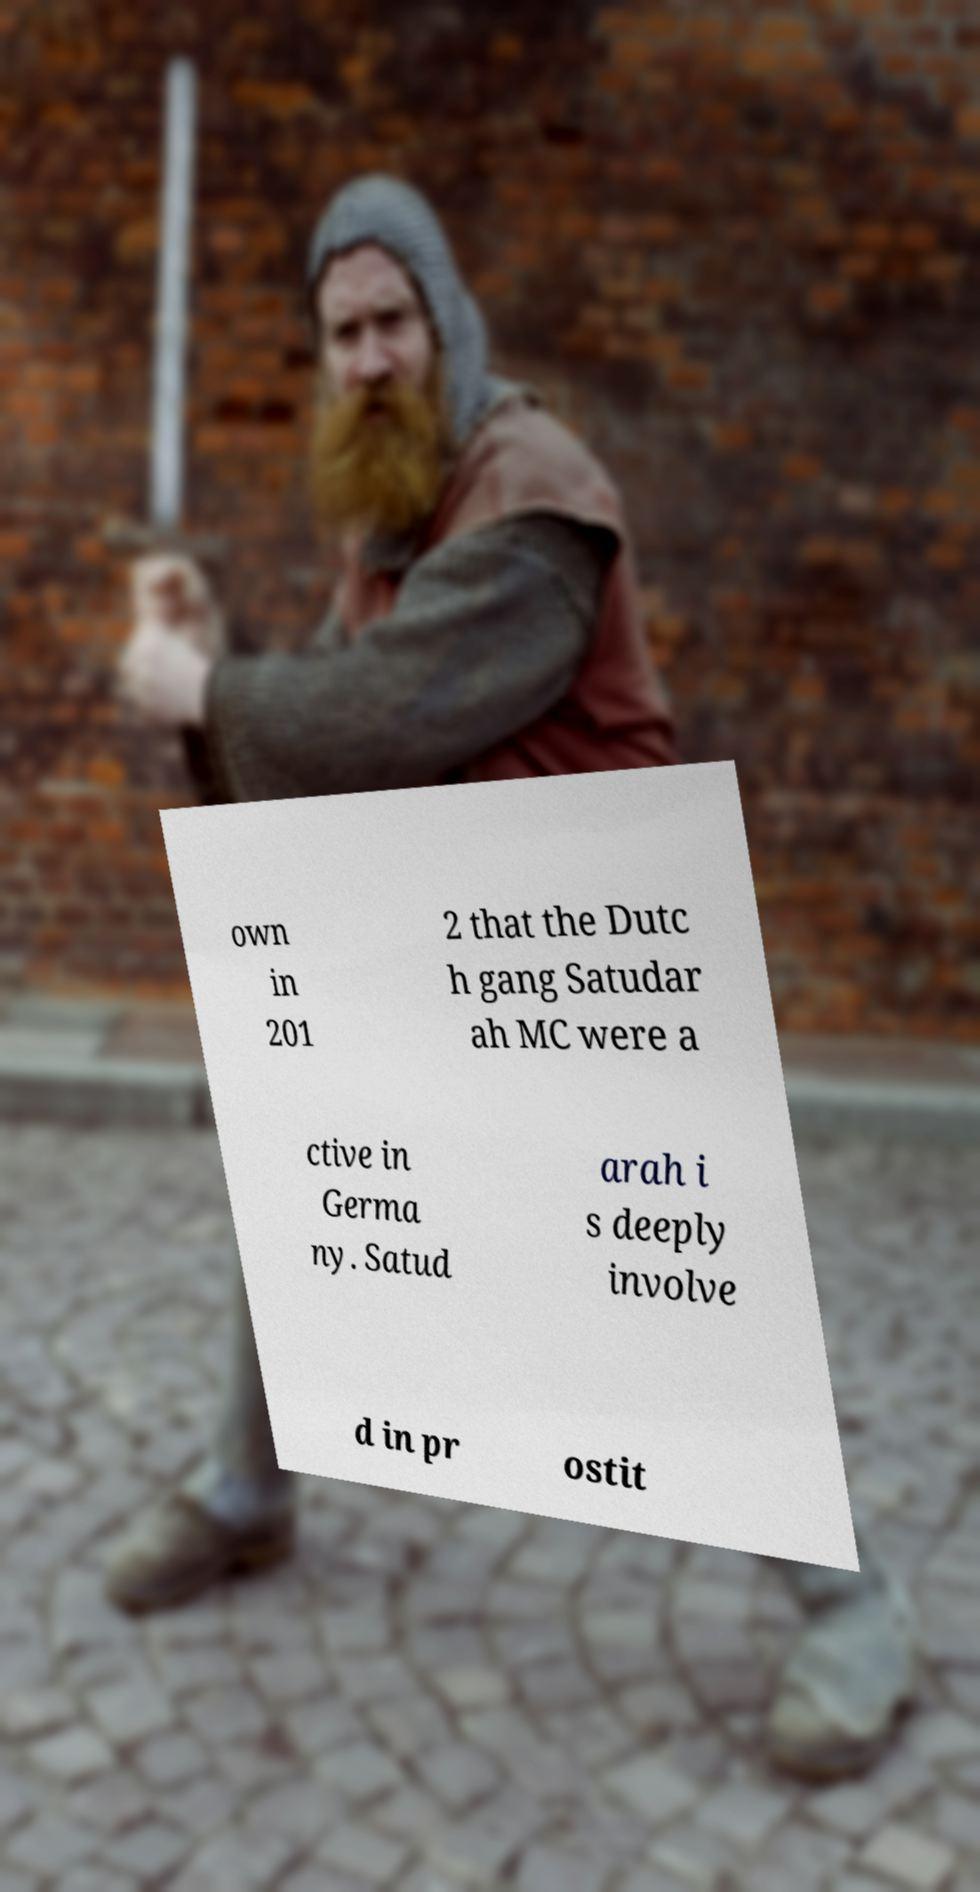There's text embedded in this image that I need extracted. Can you transcribe it verbatim? own in 201 2 that the Dutc h gang Satudar ah MC were a ctive in Germa ny. Satud arah i s deeply involve d in pr ostit 